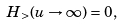Convert formula to latex. <formula><loc_0><loc_0><loc_500><loc_500>H _ { > } ( u \rightarrow \infty ) = 0 ,</formula> 